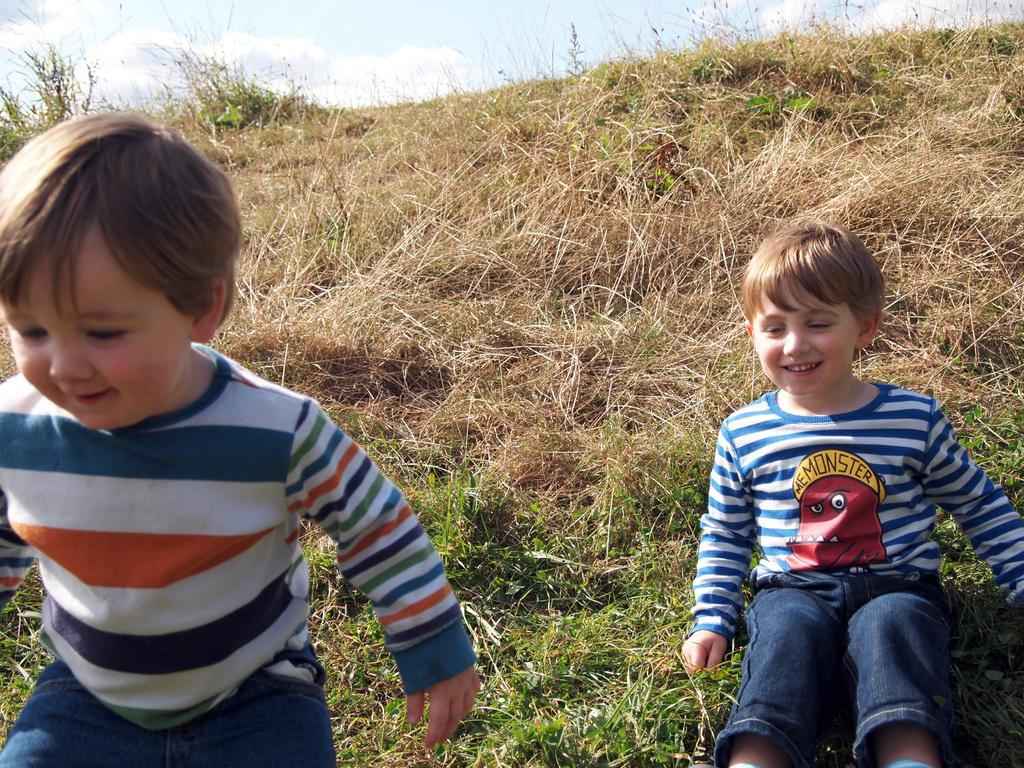What is the person in the image doing? There is a person sitting on the grass in the image. Can you describe the position of the other person in the image? There is a person standing in the image. What can be seen in the background of the image? The sky is visible in the background of the image. How many frogs are hopping in the office in the image? There is no office or frogs present in the image. 